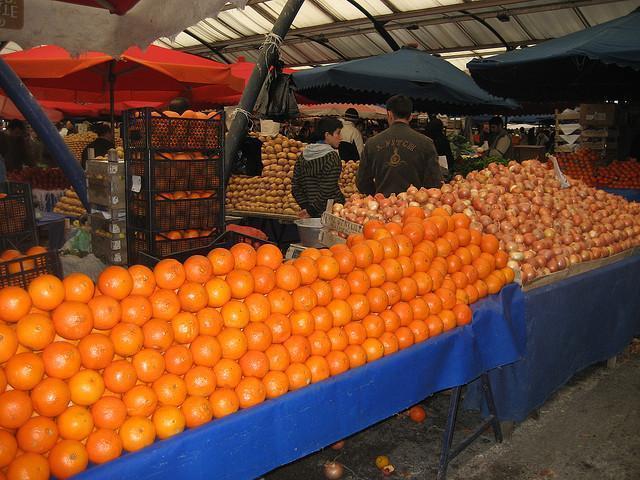How many umbrellas are in the photo?
Give a very brief answer. 3. How many people are there?
Give a very brief answer. 2. How many green cars in the picture?
Give a very brief answer. 0. 